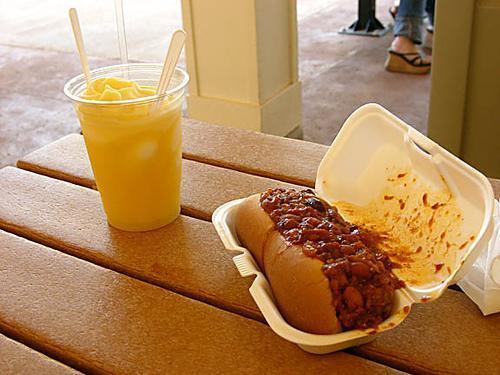Verify the accuracy of this image caption: "The person is close to the dining table.".
Answer yes or no. No. 